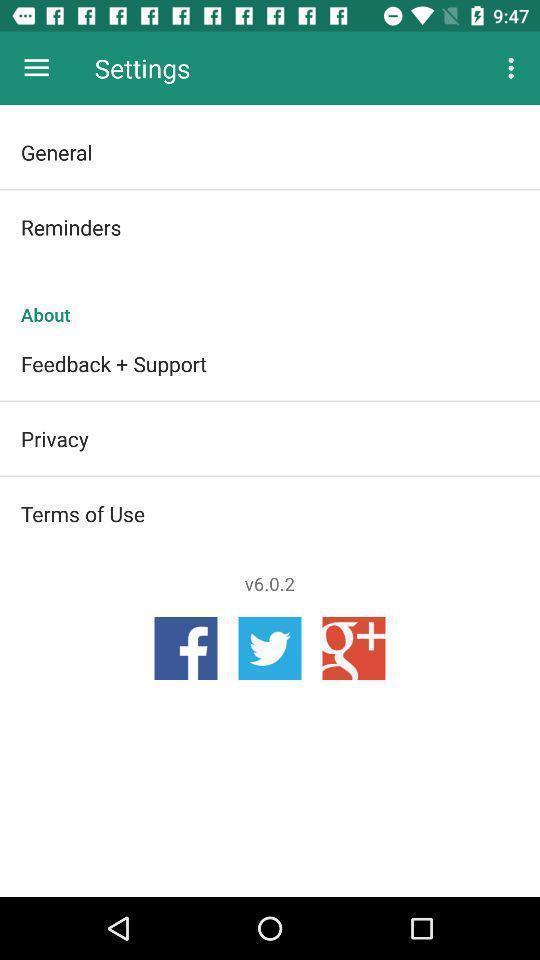Summarize the main components in this picture. Page showing about different options in settings. 